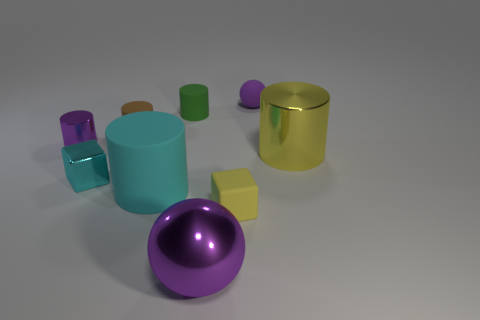Does the tiny yellow matte thing have the same shape as the purple rubber thing?
Your answer should be compact. No. There is a block on the right side of the ball in front of the small matte thing in front of the cyan metal object; how big is it?
Provide a short and direct response. Small. What is the small brown cylinder made of?
Offer a very short reply. Rubber. The matte object that is the same color as the tiny metallic cube is what size?
Offer a terse response. Large. There is a small yellow thing; is its shape the same as the purple shiny object behind the yellow metal thing?
Your answer should be compact. No. The purple sphere that is behind the rubber cylinder that is in front of the large thing to the right of the large purple ball is made of what material?
Your answer should be very brief. Rubber. How many rubber cubes are there?
Your answer should be very brief. 1. How many blue objects are rubber balls or large shiny cylinders?
Offer a terse response. 0. How many other things are there of the same shape as the large purple object?
Give a very brief answer. 1. Do the large metallic object on the right side of the big purple shiny ball and the sphere that is behind the small cyan shiny block have the same color?
Provide a succinct answer. No. 